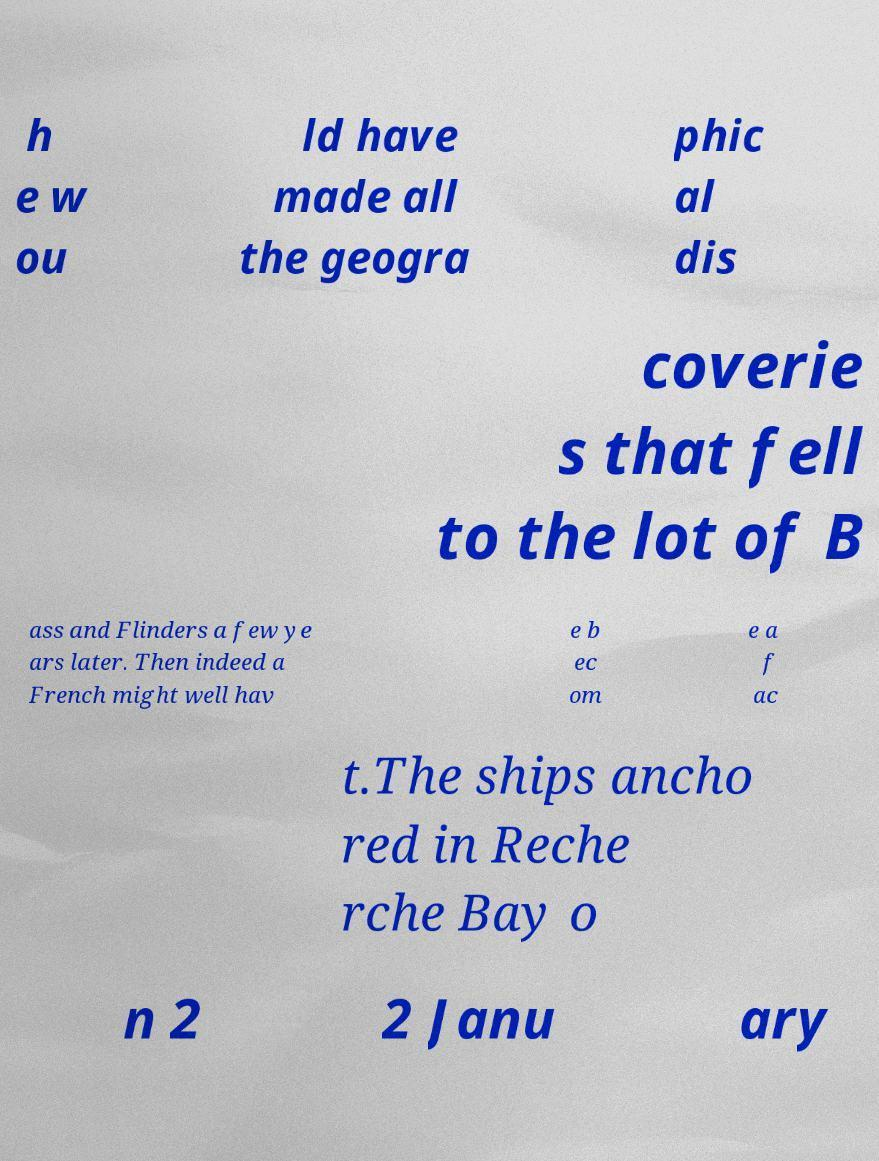Can you accurately transcribe the text from the provided image for me? h e w ou ld have made all the geogra phic al dis coverie s that fell to the lot of B ass and Flinders a few ye ars later. Then indeed a French might well hav e b ec om e a f ac t.The ships ancho red in Reche rche Bay o n 2 2 Janu ary 